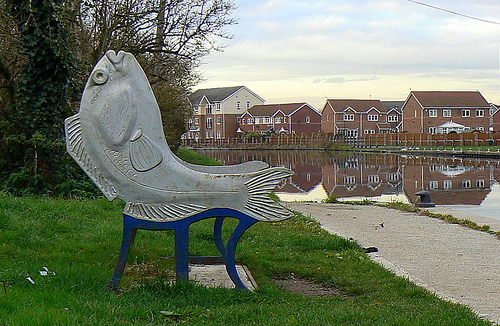<image>
Is the house behind the fin? Yes. From this viewpoint, the house is positioned behind the fin, with the fin partially or fully occluding the house. 